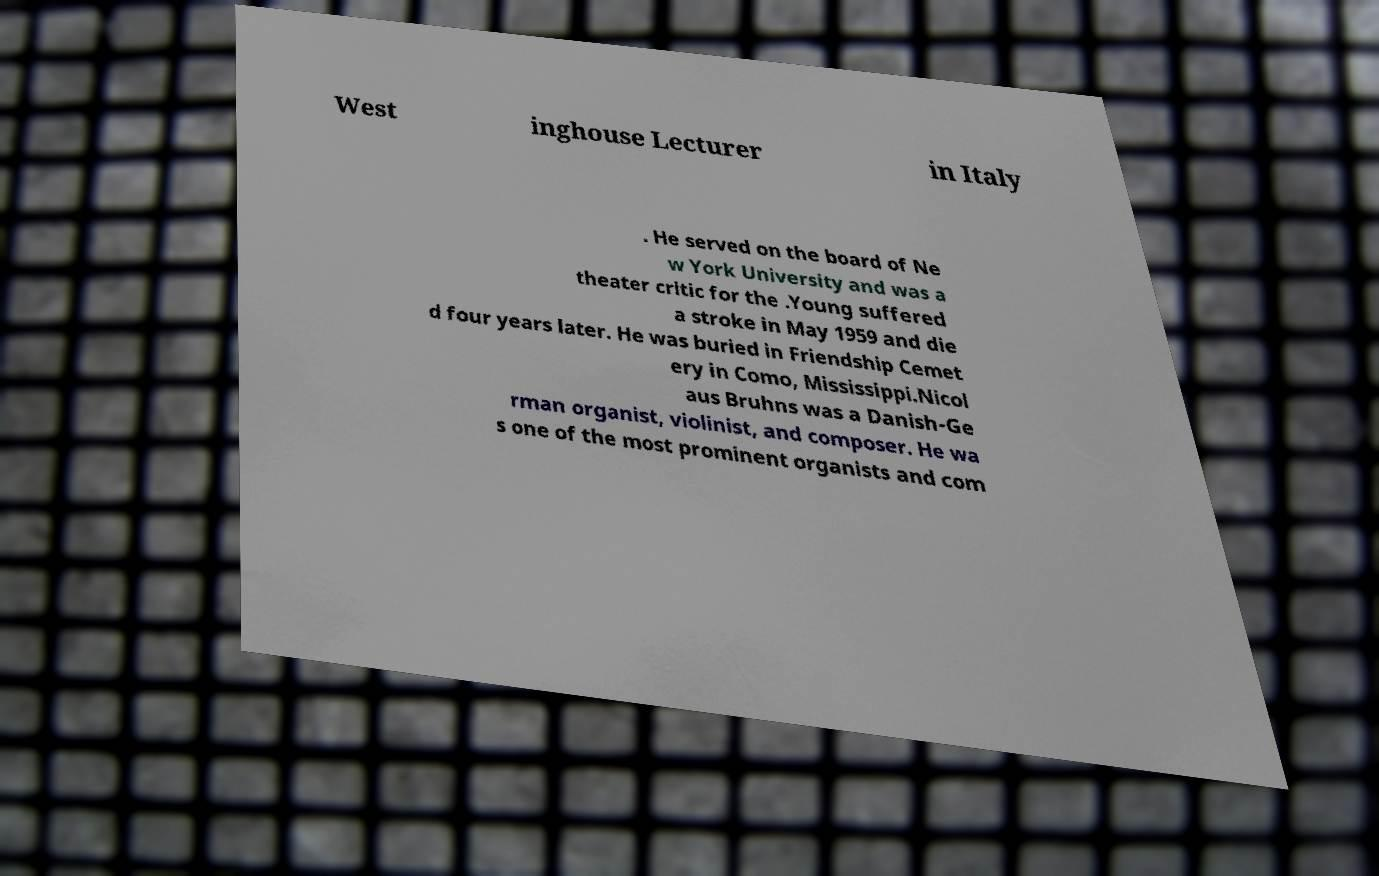Can you accurately transcribe the text from the provided image for me? West inghouse Lecturer in Italy . He served on the board of Ne w York University and was a theater critic for the .Young suffered a stroke in May 1959 and die d four years later. He was buried in Friendship Cemet ery in Como, Mississippi.Nicol aus Bruhns was a Danish-Ge rman organist, violinist, and composer. He wa s one of the most prominent organists and com 